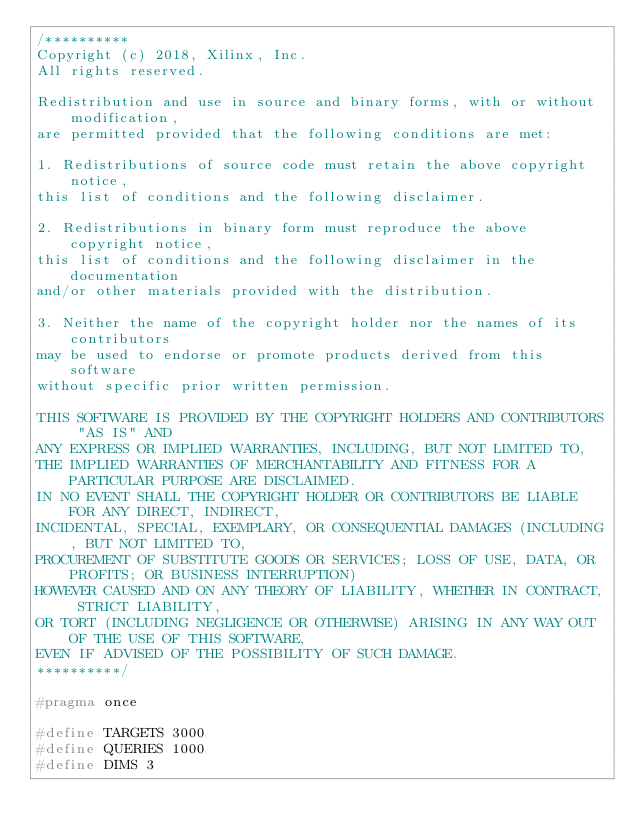<code> <loc_0><loc_0><loc_500><loc_500><_C_>/**********
Copyright (c) 2018, Xilinx, Inc.
All rights reserved.

Redistribution and use in source and binary forms, with or without modification,
are permitted provided that the following conditions are met:

1. Redistributions of source code must retain the above copyright notice,
this list of conditions and the following disclaimer.

2. Redistributions in binary form must reproduce the above copyright notice,
this list of conditions and the following disclaimer in the documentation
and/or other materials provided with the distribution.

3. Neither the name of the copyright holder nor the names of its contributors
may be used to endorse or promote products derived from this software
without specific prior written permission.

THIS SOFTWARE IS PROVIDED BY THE COPYRIGHT HOLDERS AND CONTRIBUTORS "AS IS" AND
ANY EXPRESS OR IMPLIED WARRANTIES, INCLUDING, BUT NOT LIMITED TO,
THE IMPLIED WARRANTIES OF MERCHANTABILITY AND FITNESS FOR A PARTICULAR PURPOSE ARE DISCLAIMED.
IN NO EVENT SHALL THE COPYRIGHT HOLDER OR CONTRIBUTORS BE LIABLE FOR ANY DIRECT, INDIRECT,
INCIDENTAL, SPECIAL, EXEMPLARY, OR CONSEQUENTIAL DAMAGES (INCLUDING, BUT NOT LIMITED TO,
PROCUREMENT OF SUBSTITUTE GOODS OR SERVICES; LOSS OF USE, DATA, OR PROFITS; OR BUSINESS INTERRUPTION)
HOWEVER CAUSED AND ON ANY THEORY OF LIABILITY, WHETHER IN CONTRACT, STRICT LIABILITY,
OR TORT (INCLUDING NEGLIGENCE OR OTHERWISE) ARISING IN ANY WAY OUT OF THE USE OF THIS SOFTWARE,
EVEN IF ADVISED OF THE POSSIBILITY OF SUCH DAMAGE.
**********/

#pragma once 

#define TARGETS 3000
#define QUERIES 1000
#define DIMS 3
</code> 